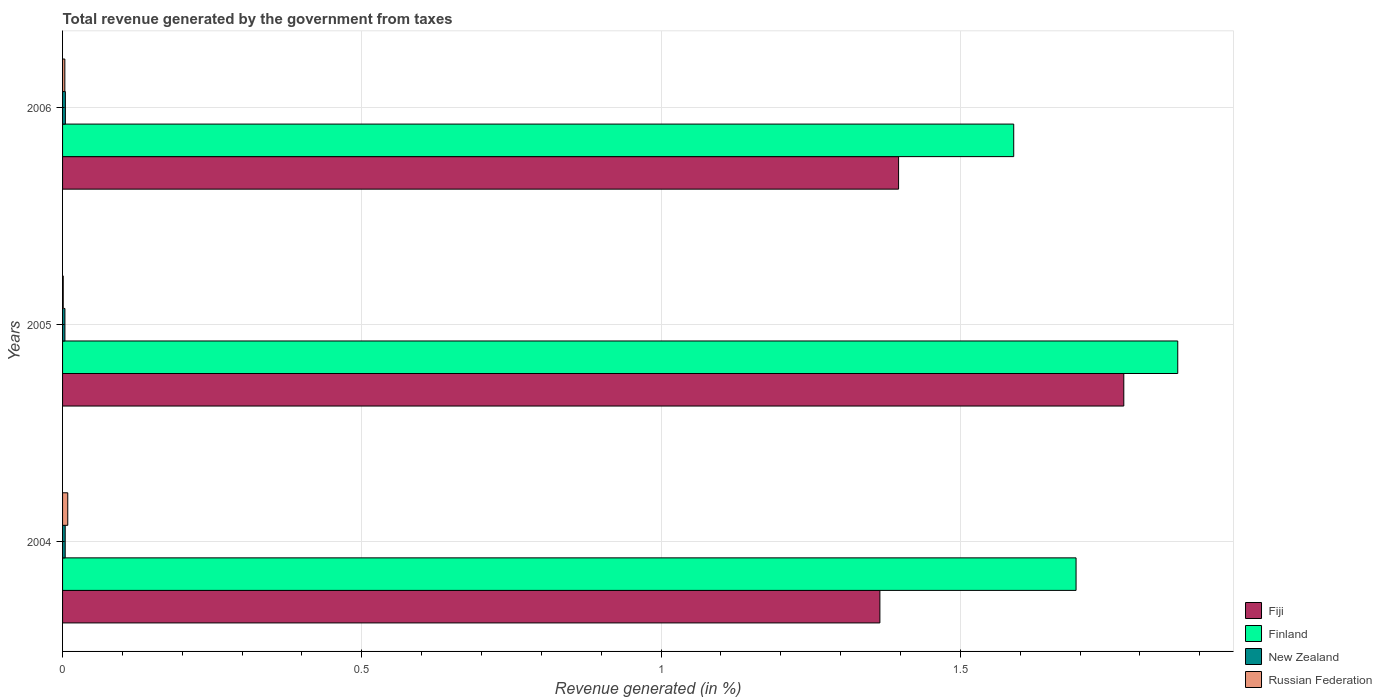How many different coloured bars are there?
Offer a very short reply. 4. How many groups of bars are there?
Your answer should be very brief. 3. Are the number of bars on each tick of the Y-axis equal?
Provide a succinct answer. Yes. What is the label of the 1st group of bars from the top?
Give a very brief answer. 2006. In how many cases, is the number of bars for a given year not equal to the number of legend labels?
Provide a succinct answer. 0. What is the total revenue generated in Russian Federation in 2006?
Your answer should be very brief. 0. Across all years, what is the maximum total revenue generated in Russian Federation?
Provide a short and direct response. 0.01. Across all years, what is the minimum total revenue generated in New Zealand?
Your response must be concise. 0. What is the total total revenue generated in New Zealand in the graph?
Offer a very short reply. 0.01. What is the difference between the total revenue generated in New Zealand in 2004 and that in 2005?
Ensure brevity in your answer.  0. What is the difference between the total revenue generated in New Zealand in 2006 and the total revenue generated in Fiji in 2005?
Your answer should be very brief. -1.77. What is the average total revenue generated in Russian Federation per year?
Ensure brevity in your answer.  0. In the year 2004, what is the difference between the total revenue generated in Finland and total revenue generated in Russian Federation?
Keep it short and to the point. 1.68. In how many years, is the total revenue generated in Finland greater than 0.4 %?
Keep it short and to the point. 3. What is the ratio of the total revenue generated in New Zealand in 2004 to that in 2005?
Offer a terse response. 1.11. Is the total revenue generated in Finland in 2004 less than that in 2005?
Your answer should be compact. Yes. Is the difference between the total revenue generated in Finland in 2004 and 2006 greater than the difference between the total revenue generated in Russian Federation in 2004 and 2006?
Offer a terse response. Yes. What is the difference between the highest and the second highest total revenue generated in Russian Federation?
Provide a short and direct response. 0. What is the difference between the highest and the lowest total revenue generated in Fiji?
Offer a terse response. 0.41. Is it the case that in every year, the sum of the total revenue generated in Russian Federation and total revenue generated in Finland is greater than the sum of total revenue generated in Fiji and total revenue generated in New Zealand?
Your answer should be very brief. Yes. What does the 4th bar from the top in 2005 represents?
Give a very brief answer. Fiji. What does the 3rd bar from the bottom in 2005 represents?
Offer a very short reply. New Zealand. Is it the case that in every year, the sum of the total revenue generated in Fiji and total revenue generated in New Zealand is greater than the total revenue generated in Russian Federation?
Provide a succinct answer. Yes. How many bars are there?
Offer a terse response. 12. Are the values on the major ticks of X-axis written in scientific E-notation?
Provide a short and direct response. No. Where does the legend appear in the graph?
Keep it short and to the point. Bottom right. How are the legend labels stacked?
Offer a terse response. Vertical. What is the title of the graph?
Keep it short and to the point. Total revenue generated by the government from taxes. Does "Slovak Republic" appear as one of the legend labels in the graph?
Your response must be concise. No. What is the label or title of the X-axis?
Your answer should be very brief. Revenue generated (in %). What is the label or title of the Y-axis?
Your response must be concise. Years. What is the Revenue generated (in %) of Fiji in 2004?
Provide a succinct answer. 1.37. What is the Revenue generated (in %) of Finland in 2004?
Your response must be concise. 1.69. What is the Revenue generated (in %) in New Zealand in 2004?
Your response must be concise. 0. What is the Revenue generated (in %) in Russian Federation in 2004?
Your response must be concise. 0.01. What is the Revenue generated (in %) in Fiji in 2005?
Offer a very short reply. 1.77. What is the Revenue generated (in %) in Finland in 2005?
Your response must be concise. 1.86. What is the Revenue generated (in %) in New Zealand in 2005?
Ensure brevity in your answer.  0. What is the Revenue generated (in %) in Russian Federation in 2005?
Your answer should be very brief. 0. What is the Revenue generated (in %) in Fiji in 2006?
Your response must be concise. 1.4. What is the Revenue generated (in %) in Finland in 2006?
Keep it short and to the point. 1.59. What is the Revenue generated (in %) of New Zealand in 2006?
Offer a terse response. 0. What is the Revenue generated (in %) of Russian Federation in 2006?
Give a very brief answer. 0. Across all years, what is the maximum Revenue generated (in %) of Fiji?
Make the answer very short. 1.77. Across all years, what is the maximum Revenue generated (in %) in Finland?
Provide a short and direct response. 1.86. Across all years, what is the maximum Revenue generated (in %) of New Zealand?
Offer a very short reply. 0. Across all years, what is the maximum Revenue generated (in %) of Russian Federation?
Provide a succinct answer. 0.01. Across all years, what is the minimum Revenue generated (in %) in Fiji?
Your answer should be compact. 1.37. Across all years, what is the minimum Revenue generated (in %) of Finland?
Provide a short and direct response. 1.59. Across all years, what is the minimum Revenue generated (in %) of New Zealand?
Keep it short and to the point. 0. Across all years, what is the minimum Revenue generated (in %) of Russian Federation?
Give a very brief answer. 0. What is the total Revenue generated (in %) in Fiji in the graph?
Your answer should be very brief. 4.54. What is the total Revenue generated (in %) in Finland in the graph?
Your answer should be compact. 5.15. What is the total Revenue generated (in %) of New Zealand in the graph?
Provide a succinct answer. 0.01. What is the total Revenue generated (in %) in Russian Federation in the graph?
Your response must be concise. 0.01. What is the difference between the Revenue generated (in %) of Fiji in 2004 and that in 2005?
Give a very brief answer. -0.41. What is the difference between the Revenue generated (in %) of Finland in 2004 and that in 2005?
Your response must be concise. -0.17. What is the difference between the Revenue generated (in %) in Russian Federation in 2004 and that in 2005?
Keep it short and to the point. 0.01. What is the difference between the Revenue generated (in %) in Fiji in 2004 and that in 2006?
Keep it short and to the point. -0.03. What is the difference between the Revenue generated (in %) of Finland in 2004 and that in 2006?
Your answer should be compact. 0.1. What is the difference between the Revenue generated (in %) of New Zealand in 2004 and that in 2006?
Offer a very short reply. -0. What is the difference between the Revenue generated (in %) of Russian Federation in 2004 and that in 2006?
Your response must be concise. 0. What is the difference between the Revenue generated (in %) in Fiji in 2005 and that in 2006?
Make the answer very short. 0.38. What is the difference between the Revenue generated (in %) in Finland in 2005 and that in 2006?
Ensure brevity in your answer.  0.27. What is the difference between the Revenue generated (in %) of New Zealand in 2005 and that in 2006?
Give a very brief answer. -0. What is the difference between the Revenue generated (in %) of Russian Federation in 2005 and that in 2006?
Provide a short and direct response. -0. What is the difference between the Revenue generated (in %) of Fiji in 2004 and the Revenue generated (in %) of Finland in 2005?
Give a very brief answer. -0.5. What is the difference between the Revenue generated (in %) in Fiji in 2004 and the Revenue generated (in %) in New Zealand in 2005?
Provide a short and direct response. 1.36. What is the difference between the Revenue generated (in %) in Fiji in 2004 and the Revenue generated (in %) in Russian Federation in 2005?
Your answer should be compact. 1.36. What is the difference between the Revenue generated (in %) of Finland in 2004 and the Revenue generated (in %) of New Zealand in 2005?
Give a very brief answer. 1.69. What is the difference between the Revenue generated (in %) of Finland in 2004 and the Revenue generated (in %) of Russian Federation in 2005?
Make the answer very short. 1.69. What is the difference between the Revenue generated (in %) in New Zealand in 2004 and the Revenue generated (in %) in Russian Federation in 2005?
Offer a very short reply. 0. What is the difference between the Revenue generated (in %) in Fiji in 2004 and the Revenue generated (in %) in Finland in 2006?
Give a very brief answer. -0.22. What is the difference between the Revenue generated (in %) of Fiji in 2004 and the Revenue generated (in %) of New Zealand in 2006?
Keep it short and to the point. 1.36. What is the difference between the Revenue generated (in %) in Fiji in 2004 and the Revenue generated (in %) in Russian Federation in 2006?
Your answer should be very brief. 1.36. What is the difference between the Revenue generated (in %) in Finland in 2004 and the Revenue generated (in %) in New Zealand in 2006?
Give a very brief answer. 1.69. What is the difference between the Revenue generated (in %) of Finland in 2004 and the Revenue generated (in %) of Russian Federation in 2006?
Offer a terse response. 1.69. What is the difference between the Revenue generated (in %) in New Zealand in 2004 and the Revenue generated (in %) in Russian Federation in 2006?
Provide a succinct answer. 0. What is the difference between the Revenue generated (in %) in Fiji in 2005 and the Revenue generated (in %) in Finland in 2006?
Make the answer very short. 0.18. What is the difference between the Revenue generated (in %) of Fiji in 2005 and the Revenue generated (in %) of New Zealand in 2006?
Your response must be concise. 1.77. What is the difference between the Revenue generated (in %) in Fiji in 2005 and the Revenue generated (in %) in Russian Federation in 2006?
Offer a very short reply. 1.77. What is the difference between the Revenue generated (in %) of Finland in 2005 and the Revenue generated (in %) of New Zealand in 2006?
Give a very brief answer. 1.86. What is the difference between the Revenue generated (in %) in Finland in 2005 and the Revenue generated (in %) in Russian Federation in 2006?
Give a very brief answer. 1.86. What is the average Revenue generated (in %) in Fiji per year?
Keep it short and to the point. 1.51. What is the average Revenue generated (in %) in Finland per year?
Your response must be concise. 1.72. What is the average Revenue generated (in %) of New Zealand per year?
Offer a very short reply. 0. What is the average Revenue generated (in %) in Russian Federation per year?
Give a very brief answer. 0. In the year 2004, what is the difference between the Revenue generated (in %) of Fiji and Revenue generated (in %) of Finland?
Provide a short and direct response. -0.33. In the year 2004, what is the difference between the Revenue generated (in %) of Fiji and Revenue generated (in %) of New Zealand?
Your answer should be very brief. 1.36. In the year 2004, what is the difference between the Revenue generated (in %) of Fiji and Revenue generated (in %) of Russian Federation?
Your answer should be compact. 1.36. In the year 2004, what is the difference between the Revenue generated (in %) of Finland and Revenue generated (in %) of New Zealand?
Ensure brevity in your answer.  1.69. In the year 2004, what is the difference between the Revenue generated (in %) of Finland and Revenue generated (in %) of Russian Federation?
Offer a very short reply. 1.68. In the year 2004, what is the difference between the Revenue generated (in %) in New Zealand and Revenue generated (in %) in Russian Federation?
Ensure brevity in your answer.  -0. In the year 2005, what is the difference between the Revenue generated (in %) of Fiji and Revenue generated (in %) of Finland?
Your response must be concise. -0.09. In the year 2005, what is the difference between the Revenue generated (in %) of Fiji and Revenue generated (in %) of New Zealand?
Give a very brief answer. 1.77. In the year 2005, what is the difference between the Revenue generated (in %) of Fiji and Revenue generated (in %) of Russian Federation?
Offer a terse response. 1.77. In the year 2005, what is the difference between the Revenue generated (in %) of Finland and Revenue generated (in %) of New Zealand?
Ensure brevity in your answer.  1.86. In the year 2005, what is the difference between the Revenue generated (in %) of Finland and Revenue generated (in %) of Russian Federation?
Make the answer very short. 1.86. In the year 2005, what is the difference between the Revenue generated (in %) in New Zealand and Revenue generated (in %) in Russian Federation?
Your answer should be very brief. 0. In the year 2006, what is the difference between the Revenue generated (in %) in Fiji and Revenue generated (in %) in Finland?
Provide a short and direct response. -0.19. In the year 2006, what is the difference between the Revenue generated (in %) of Fiji and Revenue generated (in %) of New Zealand?
Your answer should be very brief. 1.39. In the year 2006, what is the difference between the Revenue generated (in %) in Fiji and Revenue generated (in %) in Russian Federation?
Provide a short and direct response. 1.39. In the year 2006, what is the difference between the Revenue generated (in %) in Finland and Revenue generated (in %) in New Zealand?
Provide a succinct answer. 1.58. In the year 2006, what is the difference between the Revenue generated (in %) of Finland and Revenue generated (in %) of Russian Federation?
Make the answer very short. 1.59. In the year 2006, what is the difference between the Revenue generated (in %) of New Zealand and Revenue generated (in %) of Russian Federation?
Give a very brief answer. 0. What is the ratio of the Revenue generated (in %) in Fiji in 2004 to that in 2005?
Ensure brevity in your answer.  0.77. What is the ratio of the Revenue generated (in %) of Finland in 2004 to that in 2005?
Give a very brief answer. 0.91. What is the ratio of the Revenue generated (in %) in New Zealand in 2004 to that in 2005?
Provide a short and direct response. 1.11. What is the ratio of the Revenue generated (in %) of Russian Federation in 2004 to that in 2005?
Your answer should be very brief. 7.78. What is the ratio of the Revenue generated (in %) in Fiji in 2004 to that in 2006?
Ensure brevity in your answer.  0.98. What is the ratio of the Revenue generated (in %) in Finland in 2004 to that in 2006?
Your answer should be compact. 1.07. What is the ratio of the Revenue generated (in %) in New Zealand in 2004 to that in 2006?
Provide a succinct answer. 0.93. What is the ratio of the Revenue generated (in %) in Russian Federation in 2004 to that in 2006?
Offer a terse response. 2.29. What is the ratio of the Revenue generated (in %) in Fiji in 2005 to that in 2006?
Your answer should be very brief. 1.27. What is the ratio of the Revenue generated (in %) in Finland in 2005 to that in 2006?
Provide a succinct answer. 1.17. What is the ratio of the Revenue generated (in %) of New Zealand in 2005 to that in 2006?
Give a very brief answer. 0.84. What is the ratio of the Revenue generated (in %) of Russian Federation in 2005 to that in 2006?
Provide a succinct answer. 0.29. What is the difference between the highest and the second highest Revenue generated (in %) in Fiji?
Keep it short and to the point. 0.38. What is the difference between the highest and the second highest Revenue generated (in %) of Finland?
Ensure brevity in your answer.  0.17. What is the difference between the highest and the second highest Revenue generated (in %) in New Zealand?
Give a very brief answer. 0. What is the difference between the highest and the second highest Revenue generated (in %) of Russian Federation?
Your response must be concise. 0. What is the difference between the highest and the lowest Revenue generated (in %) in Fiji?
Your response must be concise. 0.41. What is the difference between the highest and the lowest Revenue generated (in %) in Finland?
Provide a succinct answer. 0.27. What is the difference between the highest and the lowest Revenue generated (in %) in New Zealand?
Your response must be concise. 0. What is the difference between the highest and the lowest Revenue generated (in %) of Russian Federation?
Offer a very short reply. 0.01. 